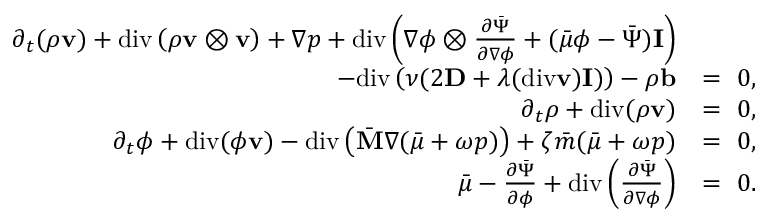<formula> <loc_0><loc_0><loc_500><loc_500>\begin{array} { r l } { \partial _ { t } ( \rho v ) + d i v \left ( \rho v \otimes v \right ) + \nabla p + d i v \left ( \nabla \phi \otimes \frac { \partial \bar { \Psi } } { \partial \nabla \phi } + ( \bar { \mu } \phi - \bar { \Psi } ) I \right ) } \\ { - d i v \left ( \nu ( 2 D + \lambda ( d i v v ) I ) \right ) - \rho b } & { = 0 , } \\ { \partial _ { t } \rho + d i v ( \rho v ) } & { = 0 , } \\ { \partial _ { t } \phi + d i v ( \phi v ) - d i v \left ( \bar { M } \nabla ( \bar { \mu } + \omega p ) \right ) + \zeta \bar { m } ( \bar { \mu } + \omega p ) } & { = 0 , } \\ { \bar { \mu } - \frac { \partial \bar { \Psi } } { \partial \phi } + d i v \left ( \frac { \partial \bar { \Psi } } { \partial \nabla \phi } \right ) } & { = 0 . } \end{array}</formula> 